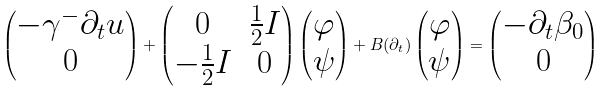Convert formula to latex. <formula><loc_0><loc_0><loc_500><loc_500>\begin{pmatrix} - \gamma ^ { - } \partial _ { t } u \\ 0 \end{pmatrix} + \begin{pmatrix} 0 & \frac { 1 } { 2 } I \\ - \frac { 1 } { 2 } I & 0 \end{pmatrix} \begin{pmatrix} \varphi \\ \psi \end{pmatrix} + B ( \partial _ { t } ) \begin{pmatrix} \varphi \\ \psi \end{pmatrix} = \begin{pmatrix} - \partial _ { t } \beta _ { 0 } \\ 0 \end{pmatrix}</formula> 